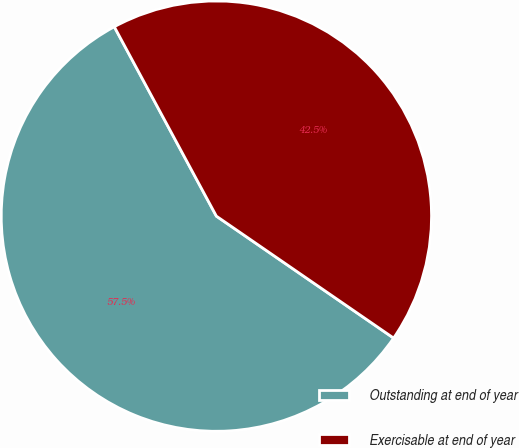<chart> <loc_0><loc_0><loc_500><loc_500><pie_chart><fcel>Outstanding at end of year<fcel>Exercisable at end of year<nl><fcel>57.54%<fcel>42.46%<nl></chart> 